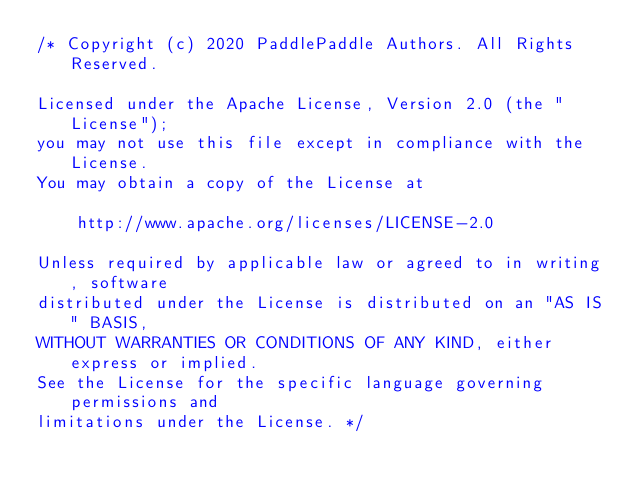Convert code to text. <code><loc_0><loc_0><loc_500><loc_500><_Cuda_>/* Copyright (c) 2020 PaddlePaddle Authors. All Rights Reserved.

Licensed under the Apache License, Version 2.0 (the "License");
you may not use this file except in compliance with the License.
You may obtain a copy of the License at

    http://www.apache.org/licenses/LICENSE-2.0

Unless required by applicable law or agreed to in writing, software
distributed under the License is distributed on an "AS IS" BASIS,
WITHOUT WARRANTIES OR CONDITIONS OF ANY KIND, either express or implied.
See the License for the specific language governing permissions and
limitations under the License. */
</code> 